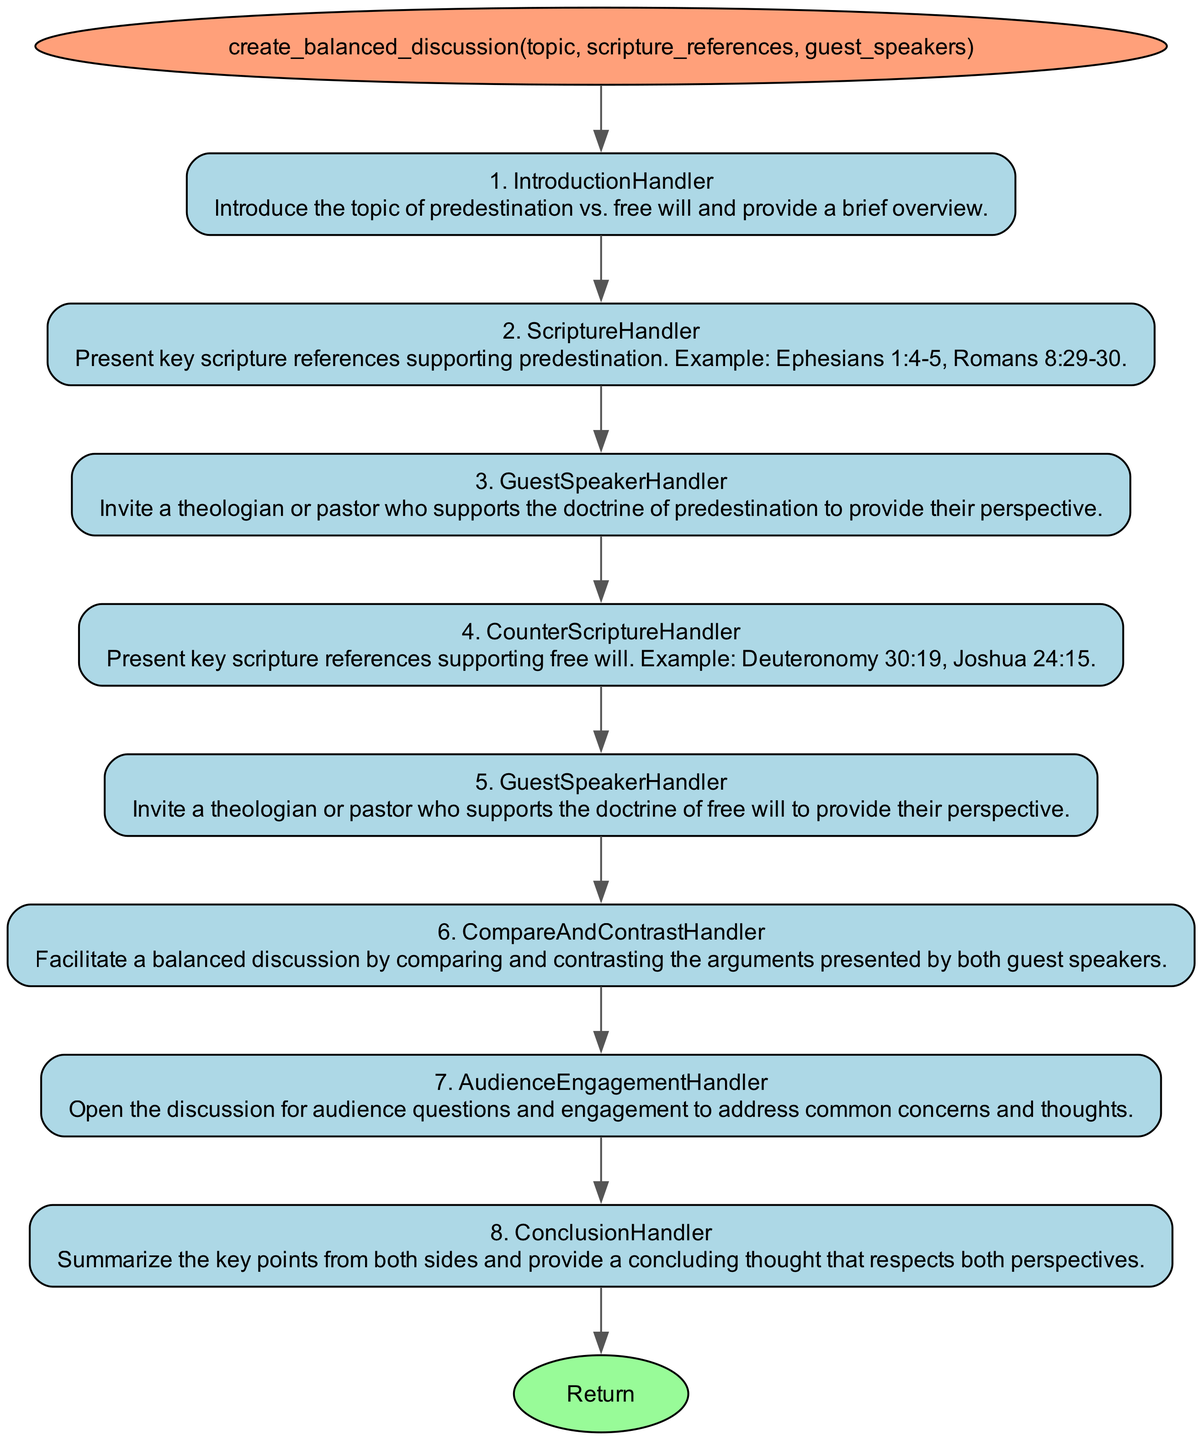What is the function name in the diagram? The function name is specified at the start of the diagram and is labeled as "create_balanced_discussion".
Answer: create_balanced_discussion How many parameters does the function have? By counting the items listed in the parameters section of the diagram, we see there are three parameters: topic, scripture references, and guest speakers.
Answer: 3 What is the first step handler in the process? The first step handler is listed in step 1 of the diagram, which shows "IntroductionHandler".
Answer: IntroductionHandler Which step compares and contrasts the arguments presented? In the flowchart, step 6 is identified as "CompareAndContrastHandler", where the arguments from both guest speakers are compared and contrasted.
Answer: CompareAndContrastHandler What key action happens in step 7 of the function? Step 7 includes the action of engaging the audience with questions, following the presentation of perspectives. This step is labeled as "AudienceEngagementHandler".
Answer: AudienceEngagementHandler What scripture references are mentioned to support predestination? In step 2 of the diagram, it lists key scripture references such as Ephesians 1:4-5 and Romans 8:29-30 to support the concept of predestination.
Answer: Ephesians 1:4-5, Romans 8:29-30 How does the diagram facilitate the discussion between opposing views? The diagram facilitates the discussion by inviting guest speakers from both perspectives, followed by a balanced comparison in step 6, promoting a respectful discourse.
Answer: By featuring guest speakers What happens after presenting scripture references for free will? After presenting the scripture references for free will in step 4, the diagram indicates the next action is to invite a guest speaker who supports the doctrine of free will in step 5.
Answer: Invite a guest speaker Which step concludes the function's discussion? The conclusion of the function is represented in step 8, labeled "ConclusionHandler," that summarizes the key points and provides a concluding thought.
Answer: ConclusionHandler 